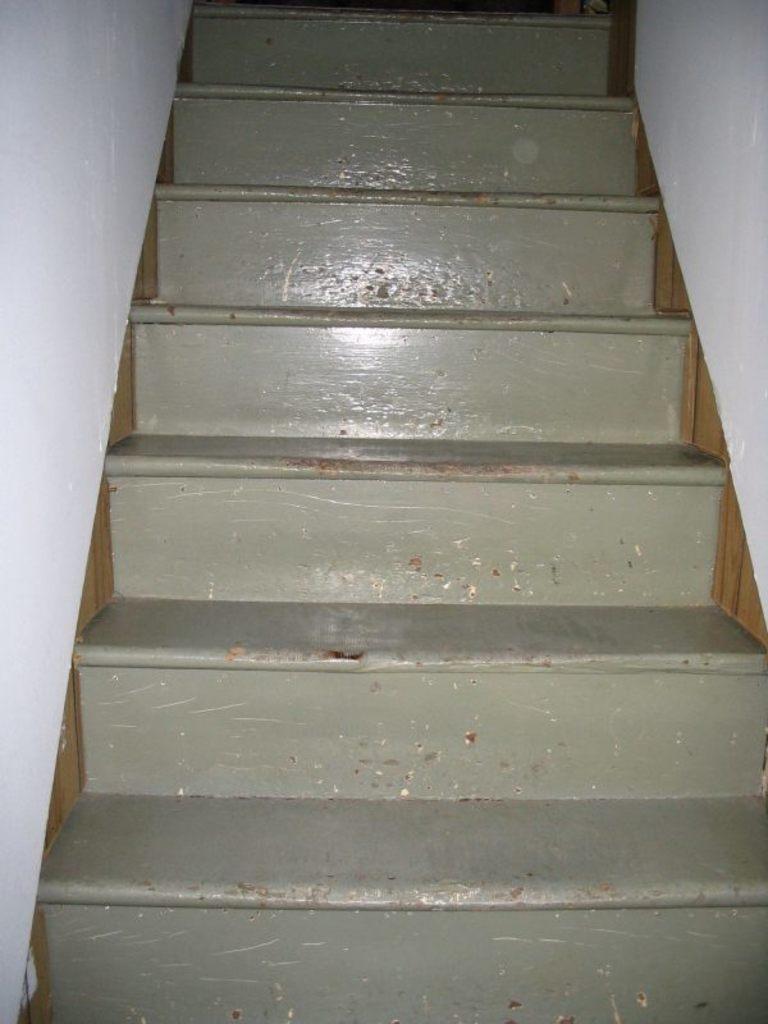Could you give a brief overview of what you see in this image? This is a zoomed in picture. In the center we can see the stairs. On the right and on the left we can see the white color walls. 